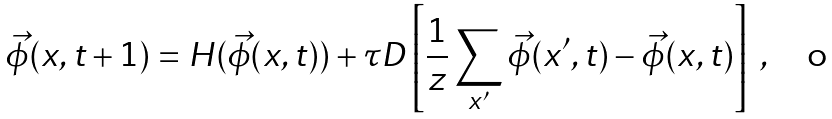<formula> <loc_0><loc_0><loc_500><loc_500>\vec { \phi } ( { x } , t + 1 ) = H ( \vec { \phi } ( { x } , t ) ) + \tau D \left [ \frac { 1 } { z } \sum _ { x ^ { \prime } } \vec { \phi } ( { x ^ { \prime } } , t ) - \vec { \phi } ( { x } , t ) \right ] \ ,</formula> 